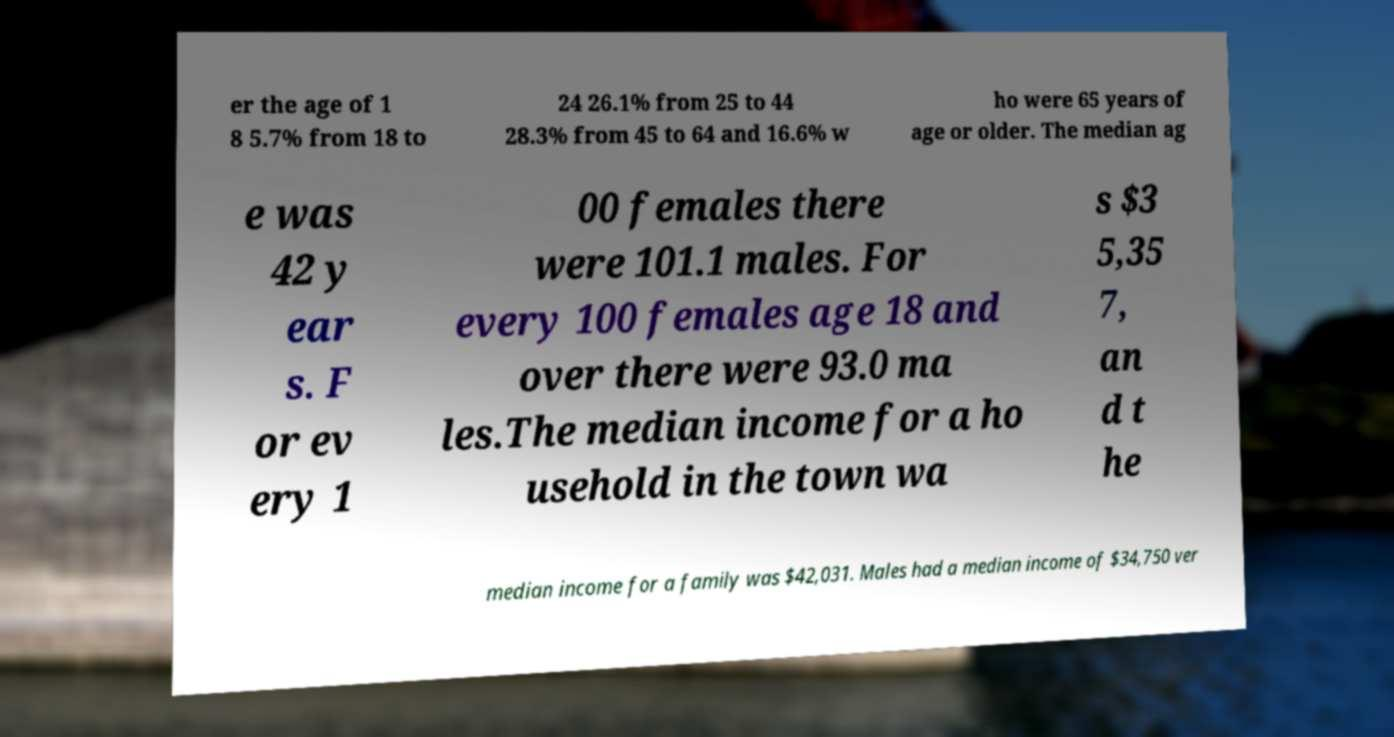What messages or text are displayed in this image? I need them in a readable, typed format. er the age of 1 8 5.7% from 18 to 24 26.1% from 25 to 44 28.3% from 45 to 64 and 16.6% w ho were 65 years of age or older. The median ag e was 42 y ear s. F or ev ery 1 00 females there were 101.1 males. For every 100 females age 18 and over there were 93.0 ma les.The median income for a ho usehold in the town wa s $3 5,35 7, an d t he median income for a family was $42,031. Males had a median income of $34,750 ver 